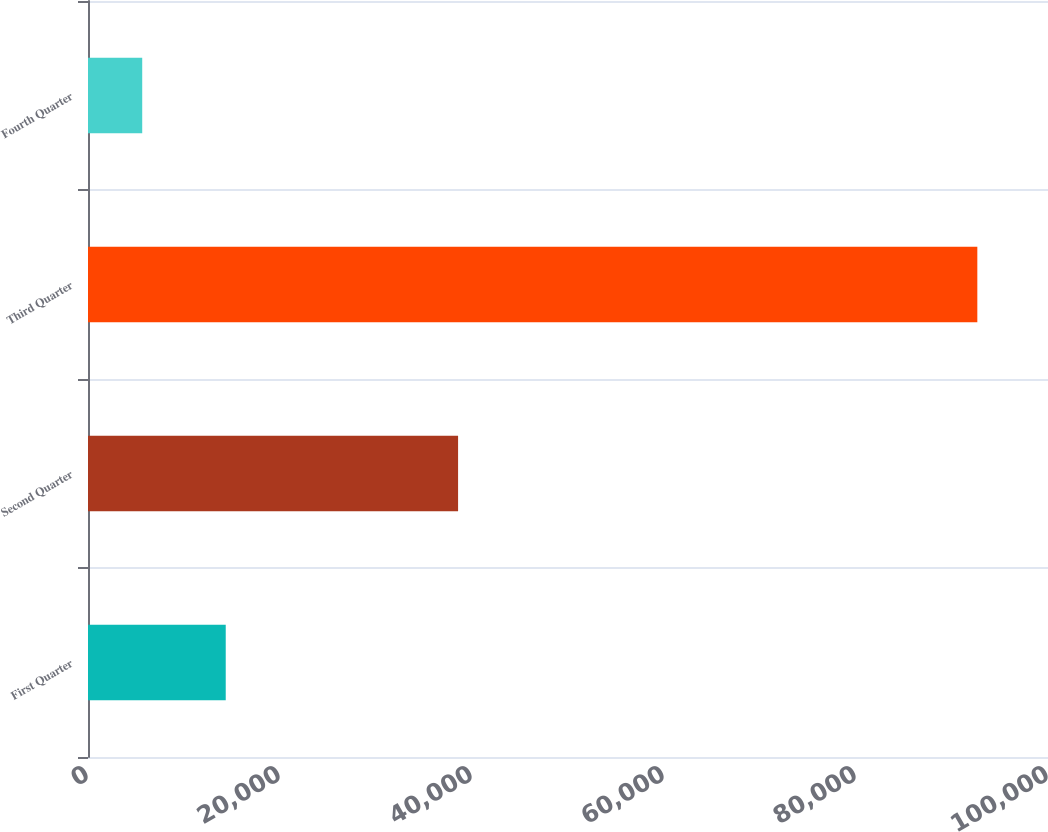Convert chart to OTSL. <chart><loc_0><loc_0><loc_500><loc_500><bar_chart><fcel>First Quarter<fcel>Second Quarter<fcel>Third Quarter<fcel>Fourth Quarter<nl><fcel>14347<fcel>38550<fcel>92638<fcel>5648<nl></chart> 